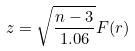Convert formula to latex. <formula><loc_0><loc_0><loc_500><loc_500>z = \sqrt { \frac { n - 3 } { 1 . 0 6 } } F ( r )</formula> 